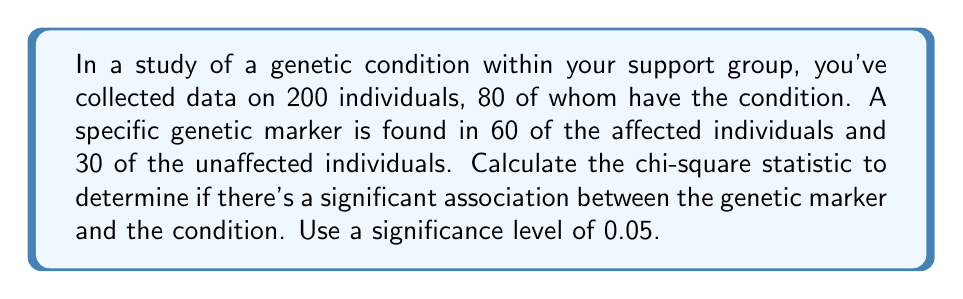Provide a solution to this math problem. To analyze the statistical significance of the genetic marker, we'll use the chi-square test of independence. Here's how to approach this problem:

1. Set up the contingency table:

   | Marker | Condition | No Condition | Total |
   |--------|-----------|--------------|-------|
   | Present| 60        | 30           | 90    |
   | Absent | 20        | 90           | 110   |
   | Total  | 80        | 120          | 200   |

2. Calculate the expected frequencies for each cell:
   
   $E = \frac{\text{row total} \times \text{column total}}{\text{grand total}}$

   For "Marker Present and Condition":
   $E_{11} = \frac{90 \times 80}{200} = 36$

   For "Marker Present and No Condition":
   $E_{12} = \frac{90 \times 120}{200} = 54$

   For "Marker Absent and Condition":
   $E_{21} = \frac{110 \times 80}{200} = 44$

   For "Marker Absent and No Condition":
   $E_{22} = \frac{110 \times 120}{200} = 66$

3. Calculate the chi-square statistic:

   $$\chi^2 = \sum\frac{(O - E)^2}{E}$$

   Where $O$ is the observed frequency and $E$ is the expected frequency.

   $$\chi^2 = \frac{(60 - 36)^2}{36} + \frac{(30 - 54)^2}{54} + \frac{(20 - 44)^2}{44} + \frac{(90 - 66)^2}{66}$$
   
   $$\chi^2 = 16 + 10.67 + 13.09 + 8.73 = 48.49$$

4. Determine the degrees of freedom:
   $df = (r - 1)(c - 1) = (2 - 1)(2 - 1) = 1$

5. Compare the calculated chi-square value to the critical value:
   For $df = 1$ and $\alpha = 0.05$, the critical value is 3.841.

   Since $48.49 > 3.841$, we reject the null hypothesis.
Answer: The chi-square statistic is 48.49. Since this value is greater than the critical value of 3.841 (for $df = 1$ and $\alpha = 0.05$), we conclude that there is a statistically significant association between the genetic marker and the condition (p < 0.05). 